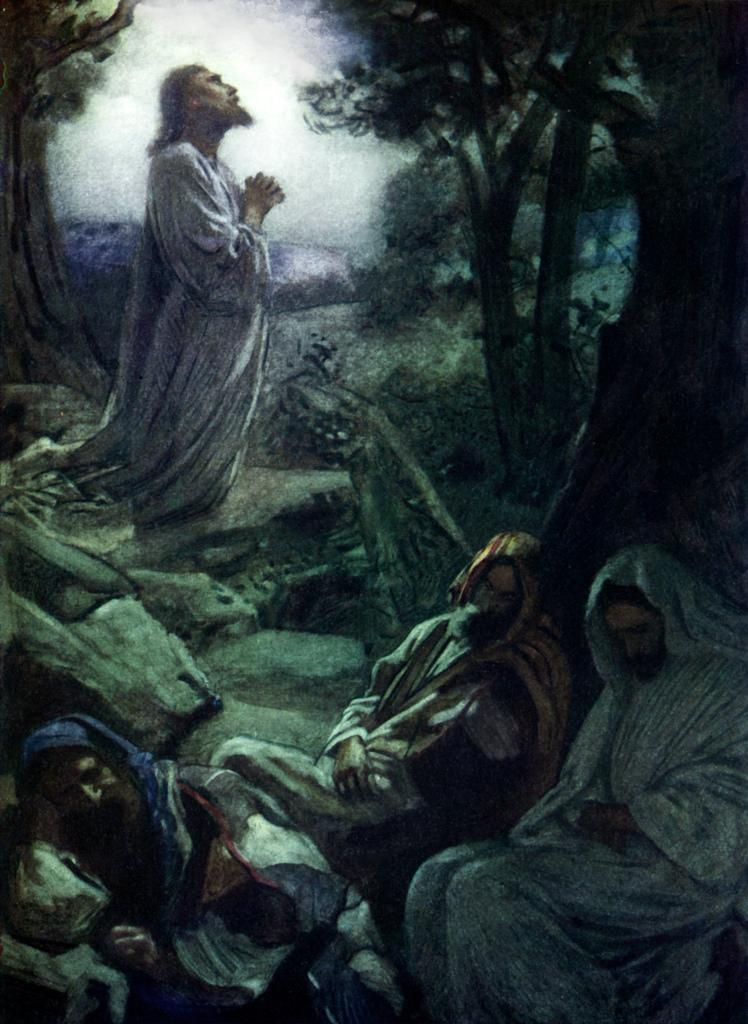What can be seen in the image involving human figures? There is a depiction of people in the image. What other elements are present in the image besides people? There is a depiction of trees in the image. What is the value of the plot of land depicted in the image? There is no mention of a plot of land or its value in the image. How many weeks have passed since the events depicted in the image? The image does not provide any information about the passage of time or the number of weeks that have passed. 